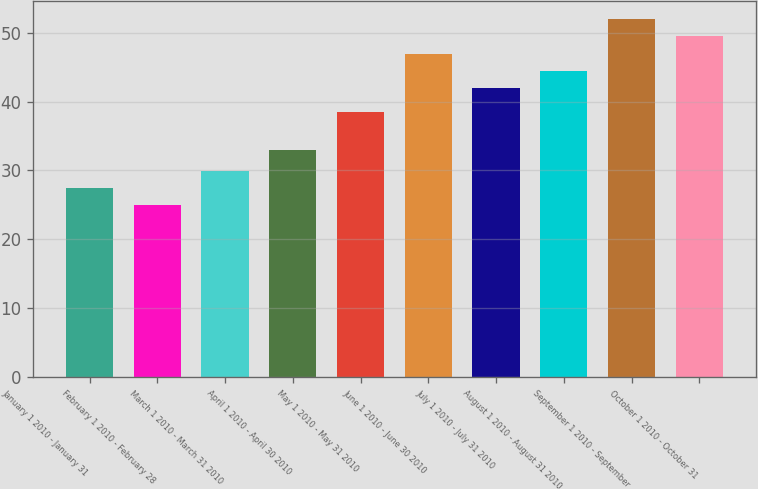Convert chart to OTSL. <chart><loc_0><loc_0><loc_500><loc_500><bar_chart><fcel>January 1 2010 - January 31<fcel>February 1 2010 - February 28<fcel>March 1 2010 - March 31 2010<fcel>April 1 2010 - April 30 2010<fcel>May 1 2010 - May 31 2010<fcel>June 1 2010 - June 30 2010<fcel>July 1 2010 - July 31 2010<fcel>August 1 2010 - August 31 2010<fcel>September 1 2010 - September<fcel>October 1 2010 - October 31<nl><fcel>27.46<fcel>24.95<fcel>29.97<fcel>32.98<fcel>38.54<fcel>46.97<fcel>41.95<fcel>44.46<fcel>51.99<fcel>49.48<nl></chart> 